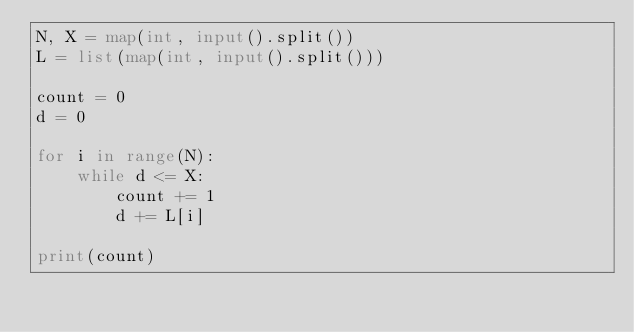Convert code to text. <code><loc_0><loc_0><loc_500><loc_500><_Python_>N, X = map(int, input().split())
L = list(map(int, input().split()))

count = 0
d = 0

for i in range(N):
    while d <= X:
        count += 1
        d += L[i]

print(count)
</code> 